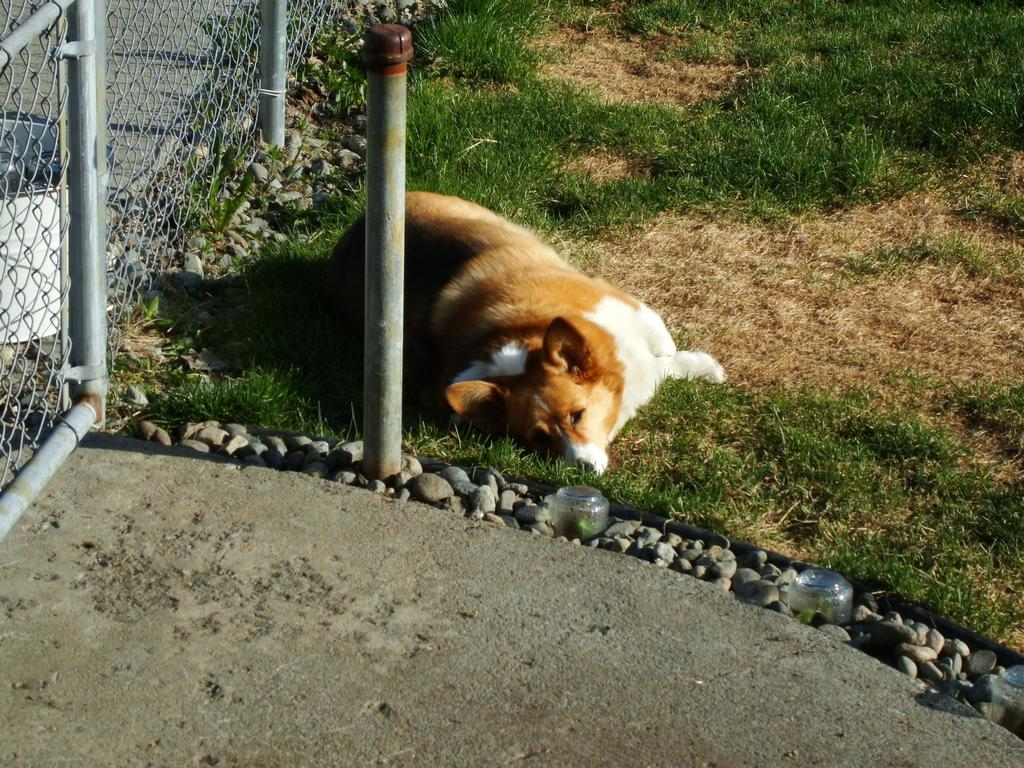What animal can be seen in the image? There is a dog lying on the grass in the image. What type of surface is the dog lying on? The dog is lying on the grass in the image. What other objects are present in the image besides the dog? Stones, a grill, the floor, and a pole are present in the image. What type of beginner's lesson is being taught in the image? There is no indication of a lesson or any teaching activity in the image. 